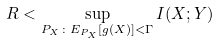<formula> <loc_0><loc_0><loc_500><loc_500>R < \sup _ { P _ { X } \colon E _ { P _ { X } } [ g ( X ) ] < \Gamma } I ( X ; Y )</formula> 